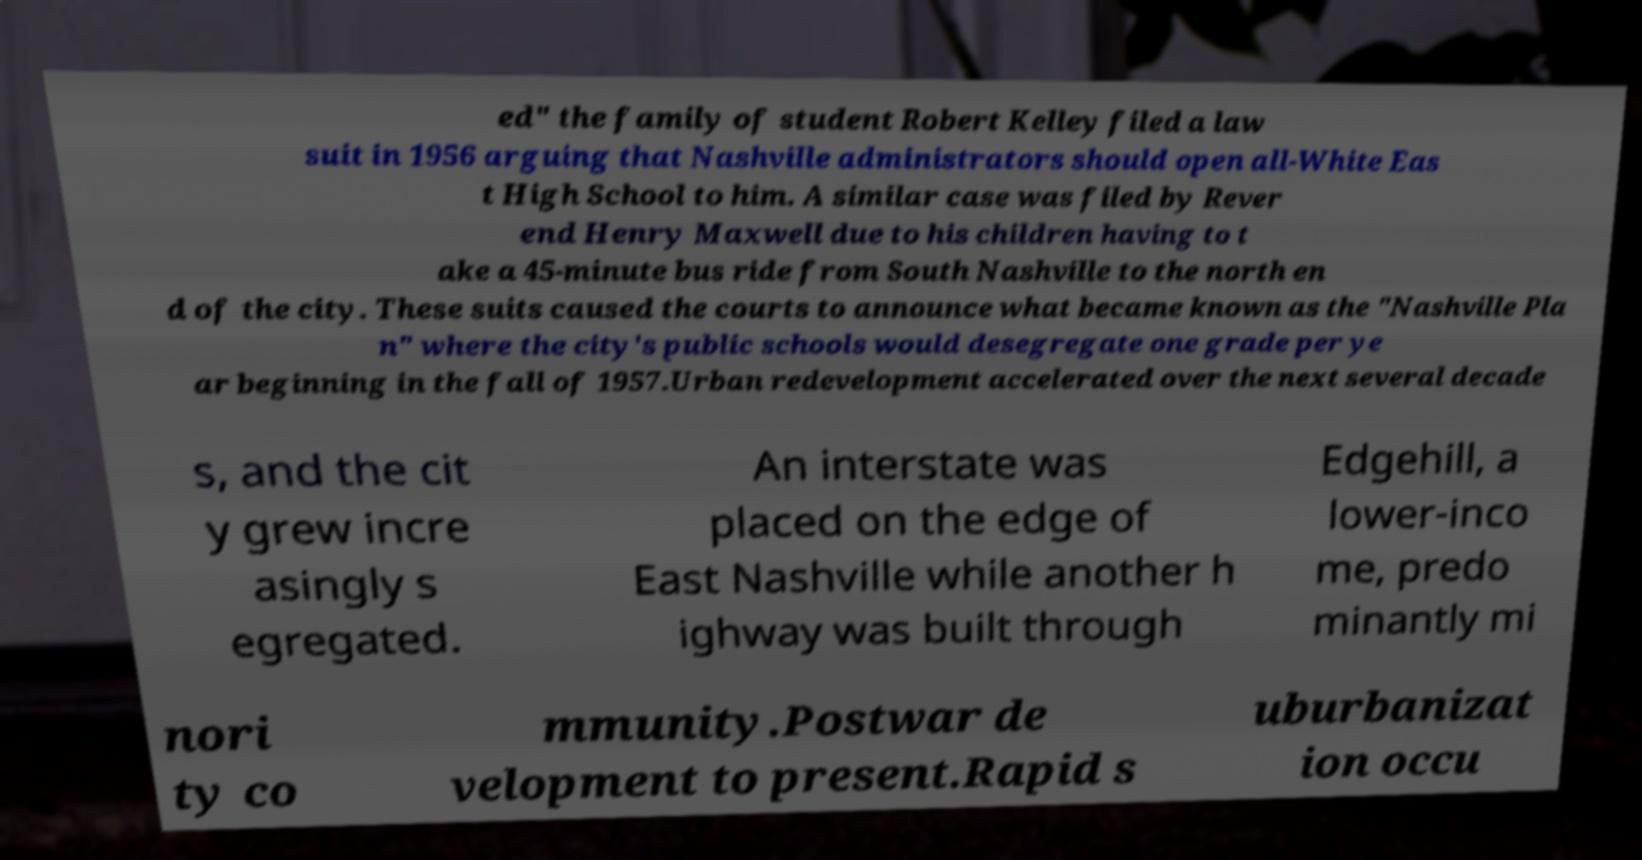Can you read and provide the text displayed in the image?This photo seems to have some interesting text. Can you extract and type it out for me? ed" the family of student Robert Kelley filed a law suit in 1956 arguing that Nashville administrators should open all-White Eas t High School to him. A similar case was filed by Rever end Henry Maxwell due to his children having to t ake a 45-minute bus ride from South Nashville to the north en d of the city. These suits caused the courts to announce what became known as the "Nashville Pla n" where the city's public schools would desegregate one grade per ye ar beginning in the fall of 1957.Urban redevelopment accelerated over the next several decade s, and the cit y grew incre asingly s egregated. An interstate was placed on the edge of East Nashville while another h ighway was built through Edgehill, a lower-inco me, predo minantly mi nori ty co mmunity.Postwar de velopment to present.Rapid s uburbanizat ion occu 